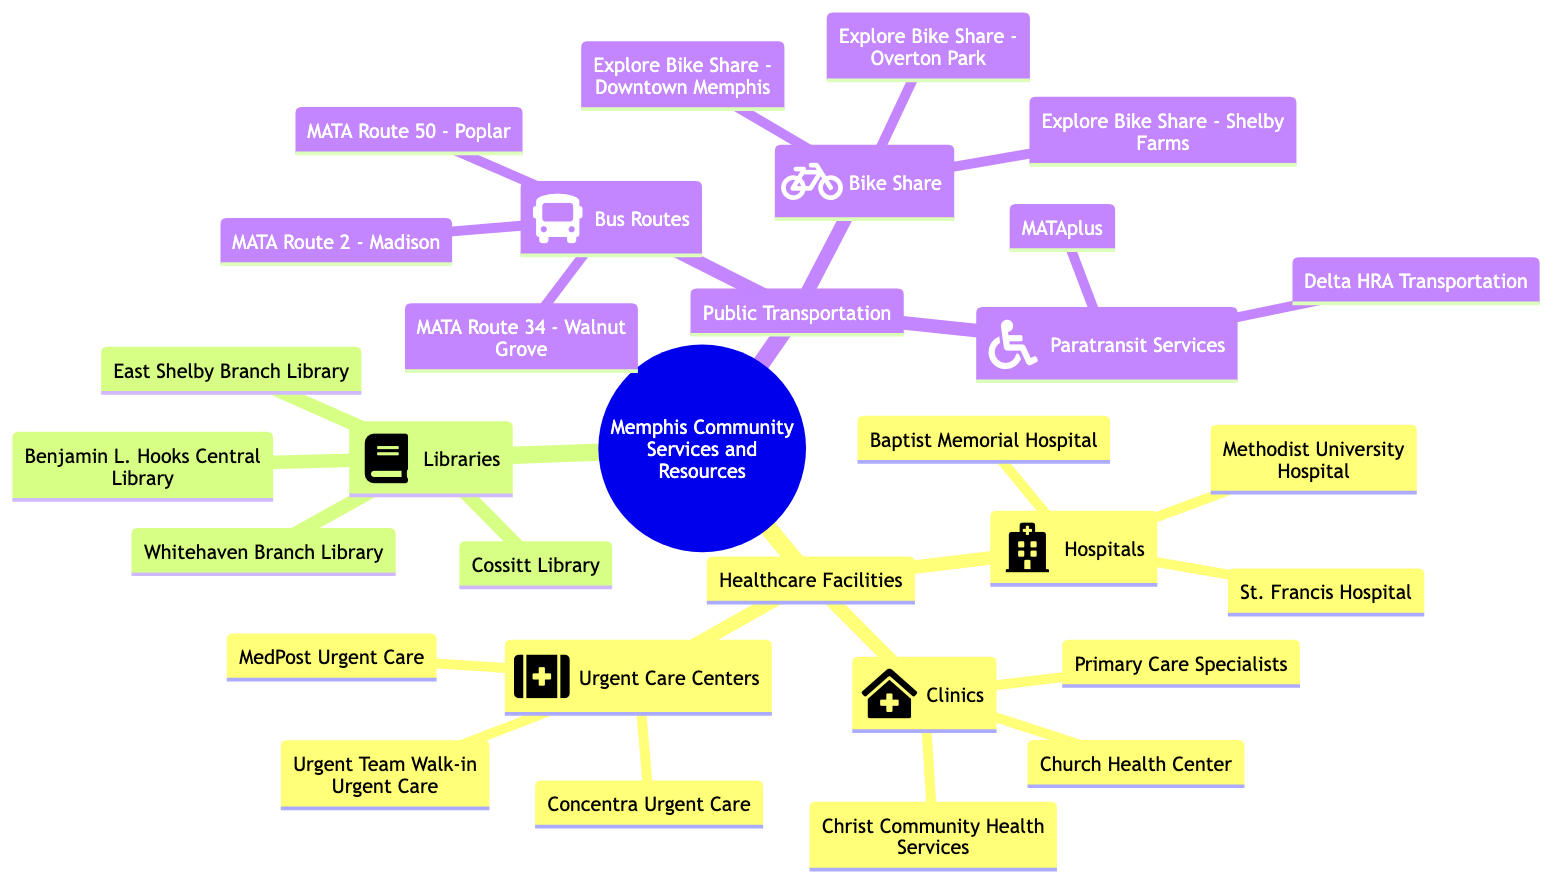What are the names of the hospitals in Memphis? The hospitals listed under the "Healthcare Facilities" section, specifically in the "Hospitals" node, are Methodist University Hospital, Baptist Memorial Hospital, and St. Francis Hospital.
Answer: Methodist University Hospital, Baptist Memorial Hospital, St. Francis Hospital How many clinics are mentioned in the diagram? The "Clinics" node under "Healthcare Facilities" contains three clinics: Christ Community Health Services, Church Health Center, and Primary Care Specialists. Therefore, the total number of clinics is three.
Answer: 3 Which library is the central library in Memphis? The "Libraries" section lists several libraries, and the specific name associated with the central library is Benjamin L. Hooks Central Library.
Answer: Benjamin L. Hooks Central Library What types of public transportation services are included? The "Public Transportation" section has sub-nodes for "Bus Routes," "Bike Share," and "Paratransit Services," indicating three different types of services provided.
Answer: 3 Which urgent care center is first in the list? In the "Urgent Care Centers" section, the first center listed is MedPost Urgent Care, indicating its position as the first entry in that node.
Answer: MedPost Urgent Care How many bus routes are listed in the diagram? The "Bus Routes" sub-node lists three specific routes: MATA Route 2 - Madison, MATA Route 34 - Walnut Grove, and MATA Route 50 - Poplar. Hence, there are three bus routes mentioned.
Answer: 3 What relationship exists between libraries and healthcare facilities? The "Libraries" and "Healthcare Facilities" sections are both part of the broader category of "Memphis Community Services and Resources," indicating that both are critical community resources available to residents.
Answer: Community resources Which bike share location is near Downtown Memphis? Within the "Bike Share" node, the specific location mentioned for Downtown Memphis is "Explore Bike Share - Downtown Memphis."
Answer: Explore Bike Share - Downtown Memphis What is the total number of immediate healthcare facilities types listed? The "Healthcare Facilities" section branches out into three types: Hospitals, Clinics, and Urgent Care Centers. Adding these three types gives us a total of three immediate types.
Answer: 3 